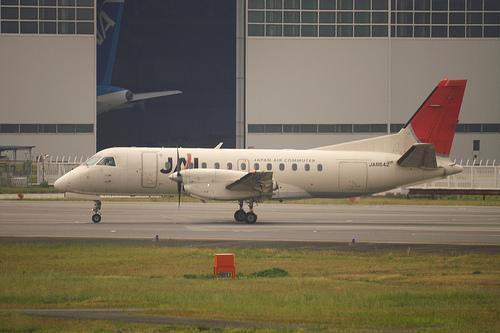How many planes are there?
Give a very brief answer. 1. 